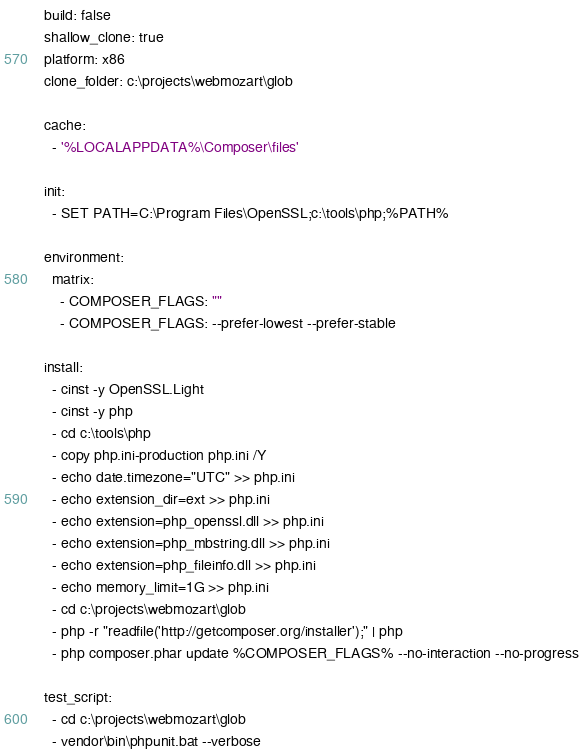Convert code to text. <code><loc_0><loc_0><loc_500><loc_500><_YAML_>build: false
shallow_clone: true
platform: x86
clone_folder: c:\projects\webmozart\glob

cache:
  - '%LOCALAPPDATA%\Composer\files'

init:
  - SET PATH=C:\Program Files\OpenSSL;c:\tools\php;%PATH%

environment:
  matrix:
    - COMPOSER_FLAGS: ""
    - COMPOSER_FLAGS: --prefer-lowest --prefer-stable

install:
  - cinst -y OpenSSL.Light
  - cinst -y php
  - cd c:\tools\php
  - copy php.ini-production php.ini /Y
  - echo date.timezone="UTC" >> php.ini
  - echo extension_dir=ext >> php.ini
  - echo extension=php_openssl.dll >> php.ini
  - echo extension=php_mbstring.dll >> php.ini
  - echo extension=php_fileinfo.dll >> php.ini
  - echo memory_limit=1G >> php.ini
  - cd c:\projects\webmozart\glob
  - php -r "readfile('http://getcomposer.org/installer');" | php
  - php composer.phar update %COMPOSER_FLAGS% --no-interaction --no-progress

test_script:
  - cd c:\projects\webmozart\glob
  - vendor\bin\phpunit.bat --verbose
</code> 